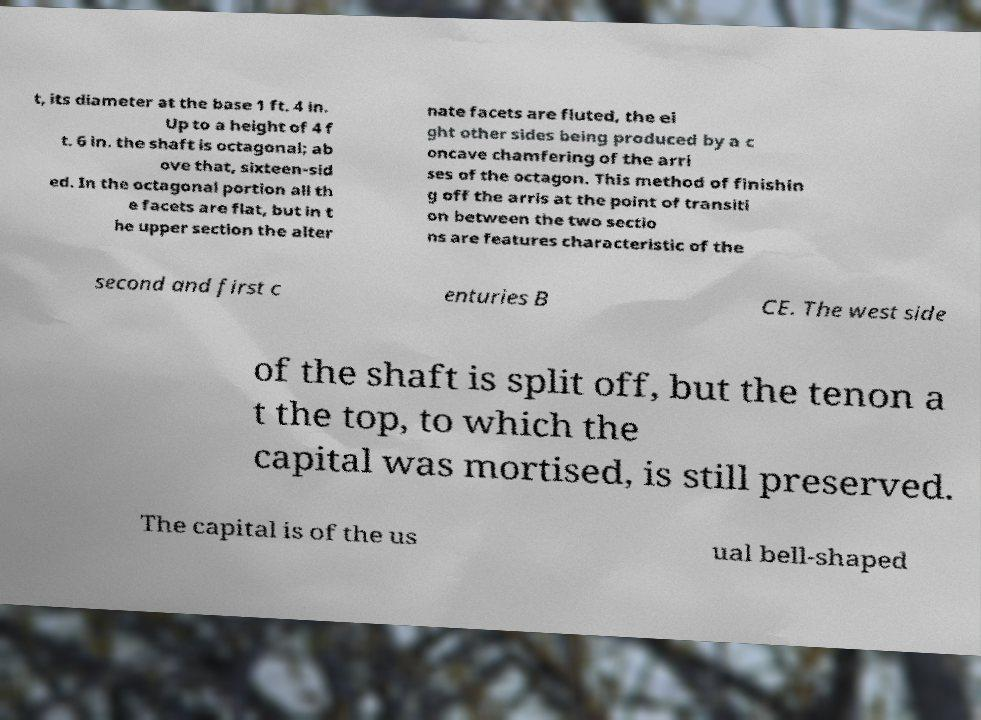Could you assist in decoding the text presented in this image and type it out clearly? t, its diameter at the base 1 ft. 4 in. Up to a height of 4 f t. 6 in. the shaft is octagonal; ab ove that, sixteen-sid ed. In the octagonal portion all th e facets are flat, but in t he upper section the alter nate facets are fluted, the ei ght other sides being produced by a c oncave chamfering of the arri ses of the octagon. This method of finishin g off the arris at the point of transiti on between the two sectio ns are features characteristic of the second and first c enturies B CE. The west side of the shaft is split off, but the tenon a t the top, to which the capital was mortised, is still preserved. The capital is of the us ual bell-shaped 